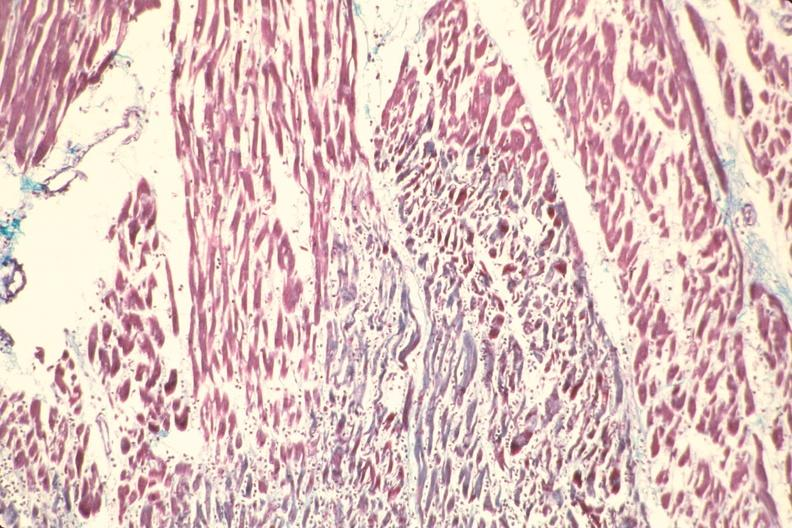do pagets disease stain?
Answer the question using a single word or phrase. No 